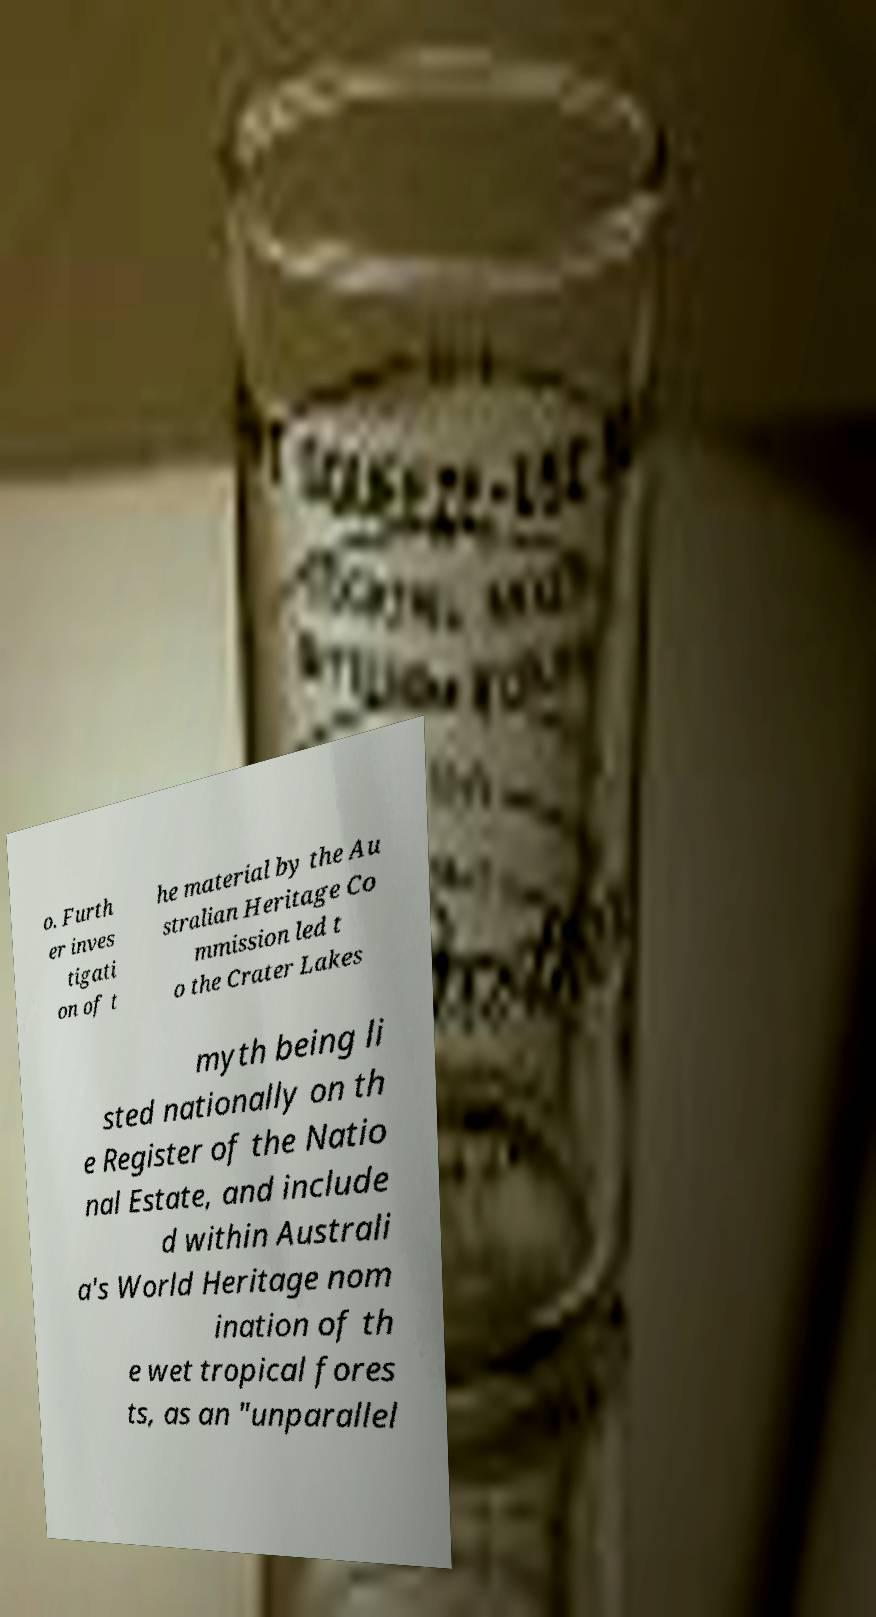Could you assist in decoding the text presented in this image and type it out clearly? o. Furth er inves tigati on of t he material by the Au stralian Heritage Co mmission led t o the Crater Lakes myth being li sted nationally on th e Register of the Natio nal Estate, and include d within Australi a's World Heritage nom ination of th e wet tropical fores ts, as an "unparallel 